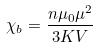<formula> <loc_0><loc_0><loc_500><loc_500>\chi _ { b } = \frac { n \mu _ { 0 } \mu ^ { 2 } } { 3 K V }</formula> 